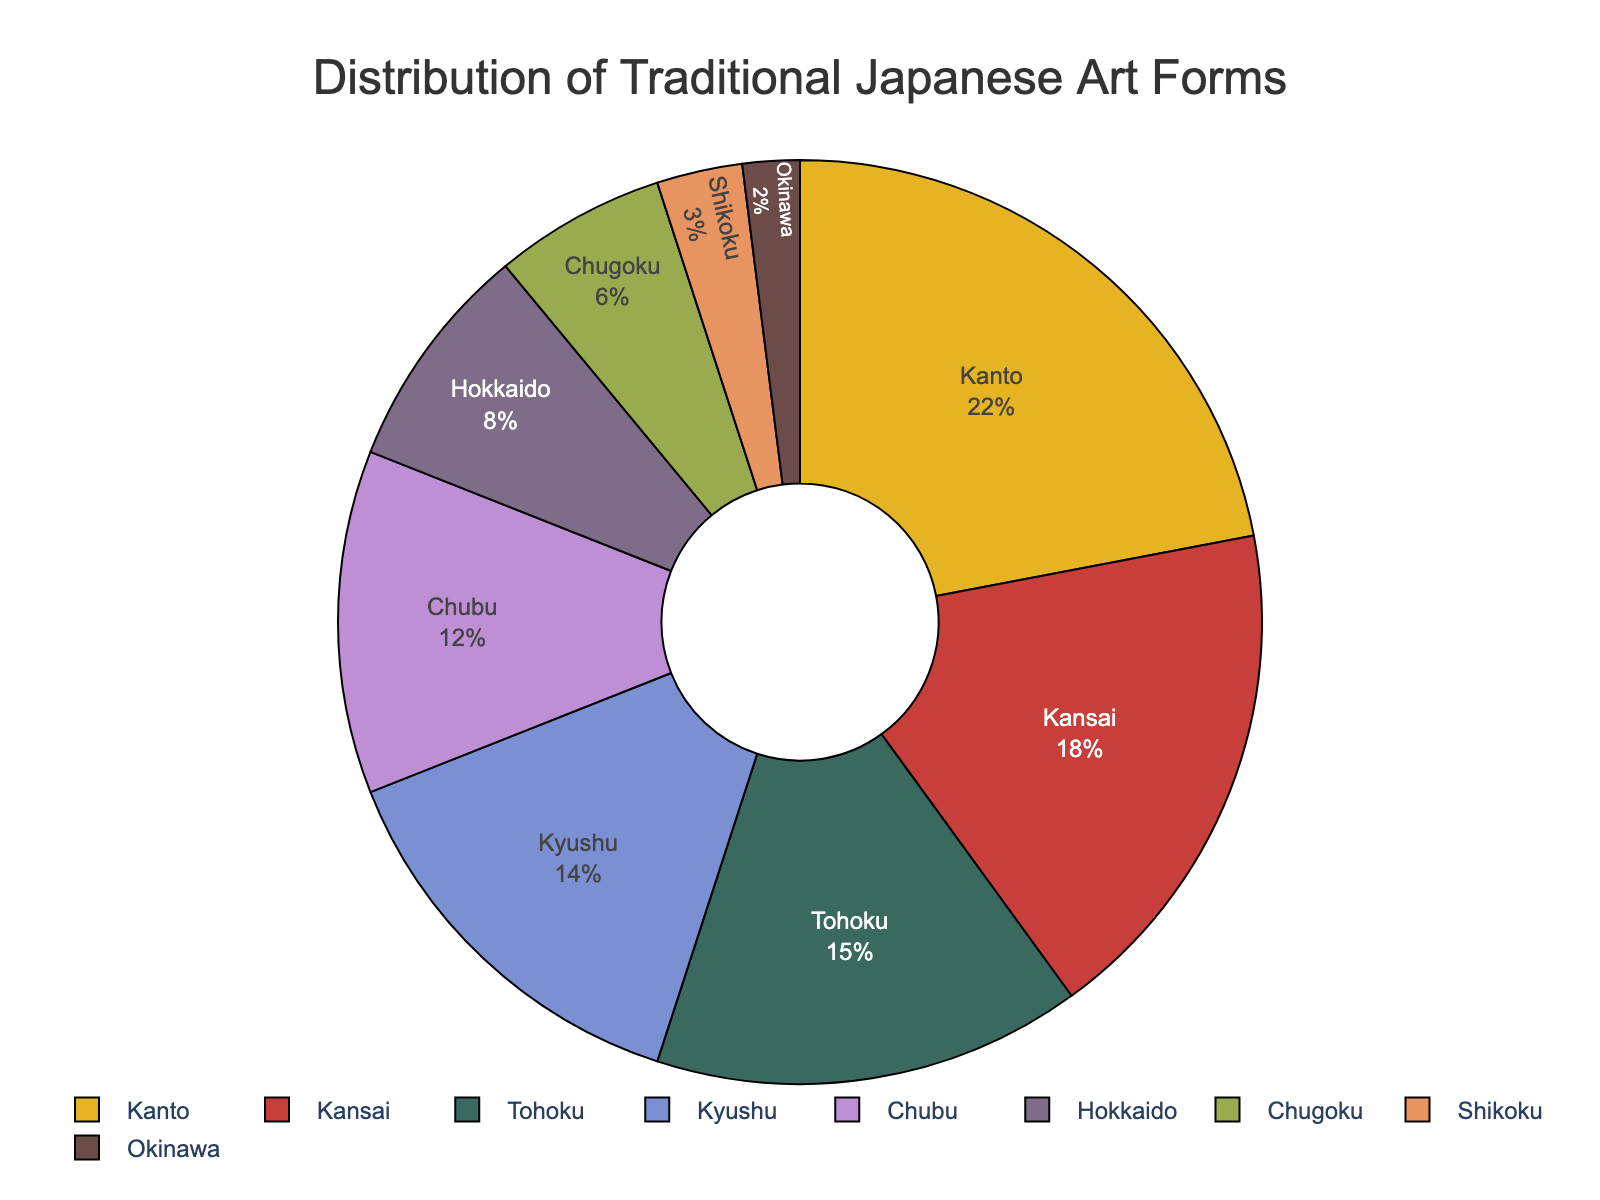What is the region with the highest percentage of traditional Japanese art forms? The region with the highest percentage can be determined by looking at the region slice with the largest size or the highest percentage value indicated inside the pie chart. Kanto has the highest percentage at 22%.
Answer: Kanto What is the combined percentage of Tohoku and Kyushu regions? Add the percentages of Tohoku and Kyushu as indicated in the pie chart: 15% (Tohoku) + 14% (Kyushu) = 29%.
Answer: 29% Which region shows the smallest percentage on the pie chart? The region with the smallest percentage is identified by looking at the smallest slice with the percentage labeled. Okinawa has the smallest percentage at 2%.
Answer: Okinawa How many regions have a percentage of traditional arts that is less than 10%? Count the regions listed in the pie chart that have a percentage value less than 10%. These are Hokkaido (8%), Chugoku (6%), Shikoku (3%), and Okinawa (2%), making a total of 4 regions.
Answer: 4 Is the percentage of traditional arts in Kyushu greater than Chubu? Compare the percentages for Kyushu and Chubu as shown in the pie chart. Kyushu is 14% while Chubu is 12%. Kyushu is greater.
Answer: Yes Which two regions have the closest percentages of traditional Japanese arts? Identify pairs of regions with similar percentages. Chubu (12%) and Hokkaido (8%) have a difference of 4%, which is closer compared to other pairs.
Answer: Chubu and Hokkaido What percentage of traditional Japanese art is contributed by regions in western Japan (Kansai, Chugoku, Shikoku, and Kyushu)? Add the percentages of Kansai, Chugoku, Shikoku, and Kyushu from the pie chart: 18% (Kansai) + 6% (Chugoku) + 3% (Shikoku) + 14% (Kyushu) = 41%.
Answer: 41% If you combine the contribution of Chugoku, Shikoku, and Okinawa, what is their total percentage? Add the percentages of Chugoku, Shikoku, and Okinawa regions: 6% (Chugoku) + 3% (Shikoku) + 2% (Okinawa) = 11%.
Answer: 11% Which region's slice is colored blue in the pie chart? Reference the pie chart's color for each region. Kansai’s slice is colored blue.
Answer: Kansai 